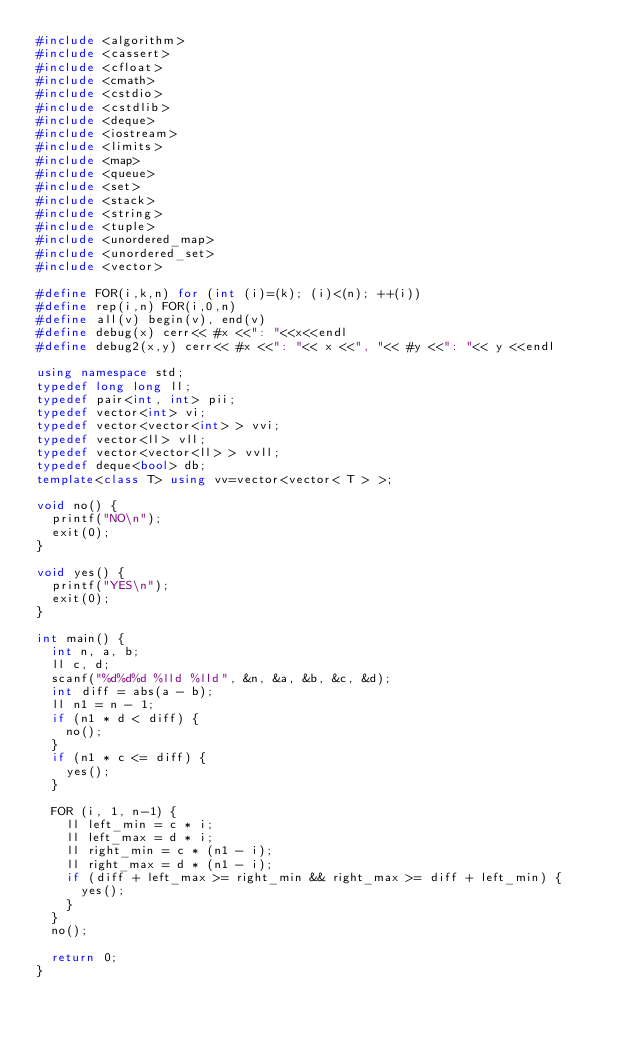<code> <loc_0><loc_0><loc_500><loc_500><_C++_>#include <algorithm>
#include <cassert>
#include <cfloat>
#include <cmath>
#include <cstdio>
#include <cstdlib>
#include <deque>
#include <iostream>
#include <limits>
#include <map>
#include <queue>
#include <set>
#include <stack>
#include <string>
#include <tuple>
#include <unordered_map>
#include <unordered_set>
#include <vector>
 
#define FOR(i,k,n) for (int (i)=(k); (i)<(n); ++(i))
#define rep(i,n) FOR(i,0,n)
#define all(v) begin(v), end(v)
#define debug(x) cerr<< #x <<": "<<x<<endl
#define debug2(x,y) cerr<< #x <<": "<< x <<", "<< #y <<": "<< y <<endl
 
using namespace std;
typedef long long ll;
typedef pair<int, int> pii;
typedef vector<int> vi;
typedef vector<vector<int> > vvi;
typedef vector<ll> vll;
typedef vector<vector<ll> > vvll;
typedef deque<bool> db;
template<class T> using vv=vector<vector< T > >;

void no() {
  printf("NO\n");
  exit(0);
}

void yes() {
  printf("YES\n");
  exit(0);
}

int main() {
  int n, a, b;
  ll c, d;
  scanf("%d%d%d %lld %lld", &n, &a, &b, &c, &d);
  int diff = abs(a - b);
  ll n1 = n - 1;
  if (n1 * d < diff) {
    no();
  }
  if (n1 * c <= diff) {
    yes();
  }

  FOR (i, 1, n-1) {
    ll left_min = c * i;
    ll left_max = d * i;
    ll right_min = c * (n1 - i);
    ll right_max = d * (n1 - i);
    if (diff + left_max >= right_min && right_max >= diff + left_min) {
      yes();
    }
  }
  no();

  return 0;
}
</code> 